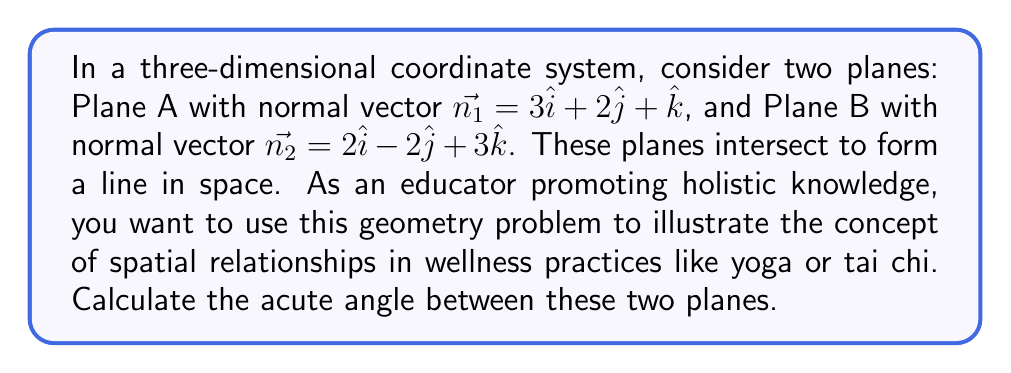Help me with this question. To find the angle between two planes, we can use the angle between their normal vectors. The process is as follows:

1) The angle $\theta$ between two vectors $\vec{a}$ and $\vec{b}$ is given by the formula:

   $$\cos \theta = \frac{\vec{a} \cdot \vec{b}}{|\vec{a}||\vec{b}|}$$

2) In our case, $\vec{a} = \vec{n_1} = 3\hat{i} + 2\hat{j} + \hat{k}$ and $\vec{b} = \vec{n_2} = 2\hat{i} - 2\hat{j} + 3\hat{k}$

3) Calculate the dot product $\vec{n_1} \cdot \vec{n_2}$:
   $$(3)(2) + (2)(-2) + (1)(3) = 6 - 4 + 3 = 5$$

4) Calculate the magnitudes:
   $$|\vec{n_1}| = \sqrt{3^2 + 2^2 + 1^2} = \sqrt{14}$$
   $$|\vec{n_2}| = \sqrt{2^2 + (-2)^2 + 3^2} = \sqrt{17}$$

5) Substitute into the formula:
   $$\cos \theta = \frac{5}{\sqrt{14}\sqrt{17}}$$

6) Take the inverse cosine (arccos) of both sides:
   $$\theta = \arccos\left(\frac{5}{\sqrt{14}\sqrt{17}}\right)$$

7) Calculate the result (in radians, then convert to degrees):
   $$\theta \approx 1.2490 \text{ radians} \approx 71.57^\circ$$

This is the angle between the normal vectors. The same angle applies between the planes.
Answer: The acute angle between the two planes is approximately $71.57^\circ$. 